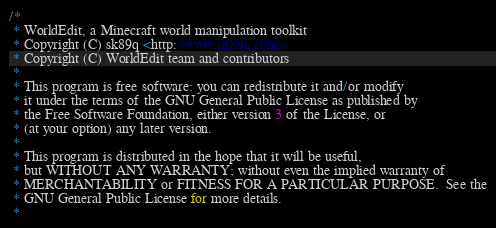<code> <loc_0><loc_0><loc_500><loc_500><_Java_>/*
 * WorldEdit, a Minecraft world manipulation toolkit
 * Copyright (C) sk89q <http://www.sk89q.com>
 * Copyright (C) WorldEdit team and contributors
 *
 * This program is free software: you can redistribute it and/or modify
 * it under the terms of the GNU General Public License as published by
 * the Free Software Foundation, either version 3 of the License, or
 * (at your option) any later version.
 *
 * This program is distributed in the hope that it will be useful,
 * but WITHOUT ANY WARRANTY; without even the implied warranty of
 * MERCHANTABILITY or FITNESS FOR A PARTICULAR PURPOSE.  See the
 * GNU General Public License for more details.
 *</code> 